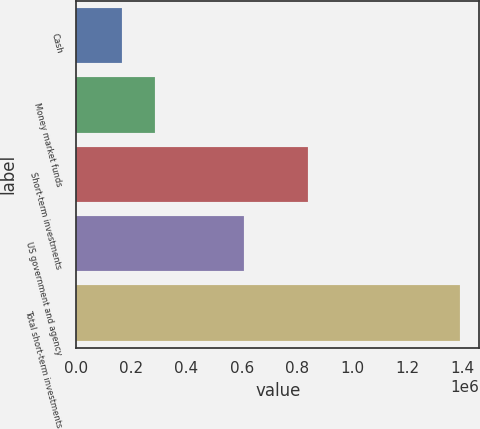Convert chart. <chart><loc_0><loc_0><loc_500><loc_500><bar_chart><fcel>Cash<fcel>Money market funds<fcel>Short-term investments<fcel>US government and agency<fcel>Total short-term investments<nl><fcel>164135<fcel>287026<fcel>841010<fcel>607508<fcel>1.39304e+06<nl></chart> 